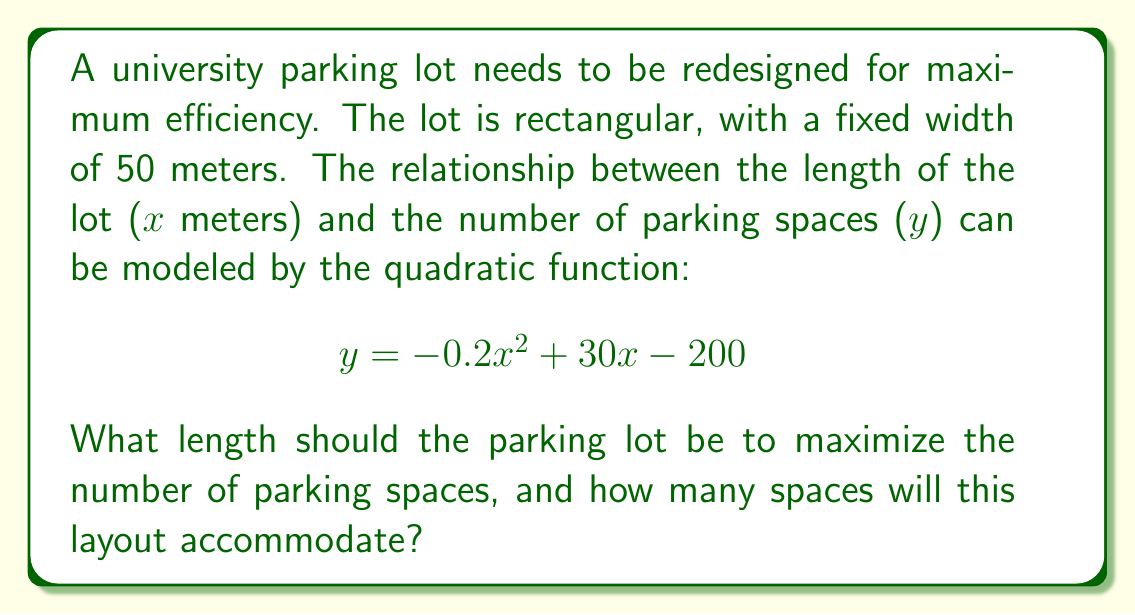Could you help me with this problem? To solve this problem, we need to find the maximum point of the given quadratic function. We can do this by following these steps:

1) The quadratic function is in the form $y = ax^2 + bx + c$, where:
   $a = -0.2$, $b = 30$, and $c = -200$

2) For a quadratic function, the x-coordinate of the vertex (which gives the maximum or minimum point) is given by the formula:

   $$ x = -\frac{b}{2a} $$

3) Substituting our values:

   $$ x = -\frac{30}{2(-0.2)} = \frac{30}{0.4} = 75 $$

4) This means the parking lot should be 75 meters long to maximize the number of spaces.

5) To find the maximum number of spaces, we substitute x = 75 into the original function:

   $$ y = -0.2(75)^2 + 30(75) - 200 $$
   $$ y = -0.2(5625) + 2250 - 200 $$
   $$ y = -1125 + 2250 - 200 $$
   $$ y = 925 $$

6) Therefore, the maximum number of parking spaces is 925.

[asy]
import graph;
size(200,200);
real f(real x) {return -0.2x^2 + 30x - 200;}
draw(graph(f,0,150));
dot((75,925));
label("(75, 925)",(75,925),NE);
xaxis("Length (m)",0,150,Arrow);
yaxis("Number of spaces",0,1000,Arrow);
[/asy]
Answer: The parking lot should be 75 meters long to maximize the number of parking spaces, which will accommodate 925 spaces. 